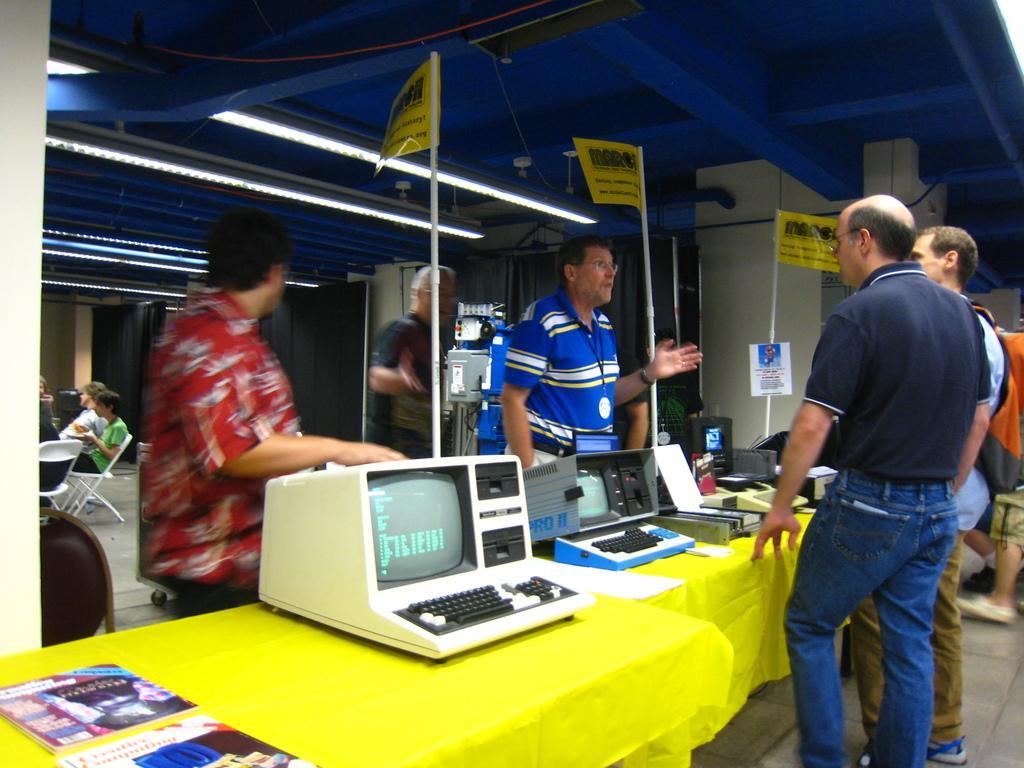Please provide a concise description of this image. In the image there is a table with yellow cloth. On the cloth there are few machines and also there are books. Behind the table there are poles with posters and also there are few men. On the right corner of the image there are two men. At the top of the image there is a ceiling with lights. On the left side of the image there are few people sitting on the chair. And in the background there are few objects. 